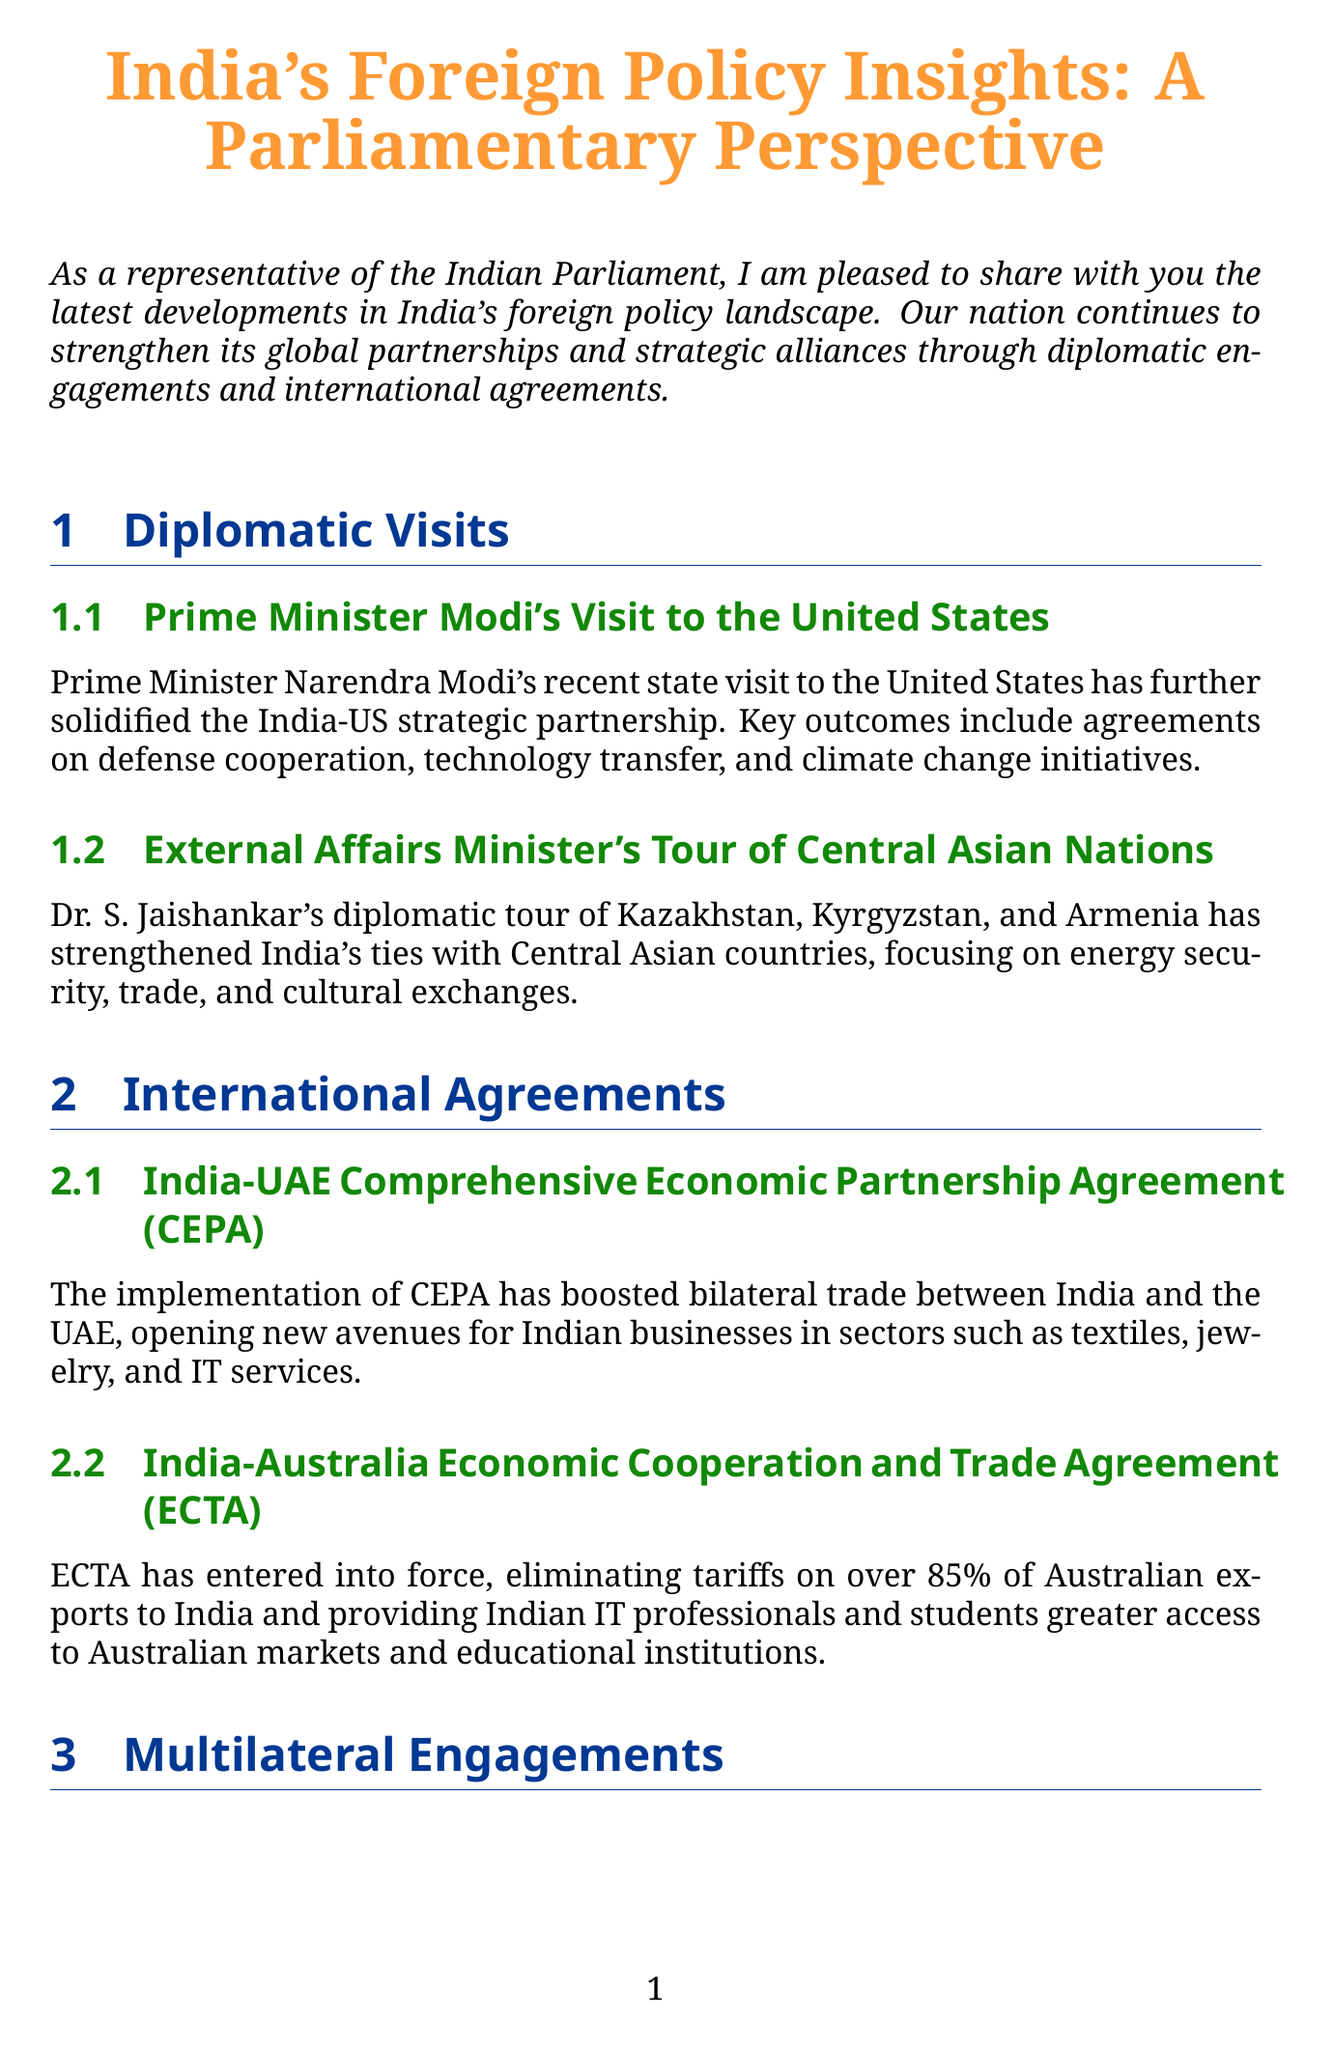What is the title of the newsletter? The title of the newsletter is found at the beginning of the document, highlighting its focus on India's foreign policy.
Answer: India's Foreign Policy Insights: A Parliamentary Perspective Who visited the United States recently? This question refers to a notable diplomatic visit mentioned in the document, specifically identifying the leader involved.
Answer: Prime Minister Modi What is one key outcome of PM Modi's visit to the US? The document lists several outcomes from the visit, focusing on a significant area of cooperation achieved.
Answer: Defense cooperation Which agreement boosts bilateral trade between India and the UAE? The document explicitly names the agreement that has facilitated trade relations between the two nations.
Answer: India-UAE Comprehensive Economic Partnership Agreement (CEPA) What percentage of Australian exports to India have tariffs eliminated under ECTA? This question seeks a specific numerical detail about the impact of ECTA as stated in the newsletter.
Answer: 85 percent What initiative focuses on regional connectivity and counter-terrorism? This question requires comprehension of India's efforts in regional initiatives mentioned in the document.
Answer: Bay of Bengal Initiative for Multi-Sectoral Technical and Economic Cooperation (BIMSTEC) How does India's G20 Presidency benefit the nation? The document explains the advantages of G20 Presidency, indicating its role in addressing specific global issues.
Answer: Leadership in addressing global challenges When is the upcoming India-Africa Forum Summit expected to occur? While the document mentions an upcoming event, it does not provide a specific date, making this a reasoning inquiry about future diplomatic engagement.
Answer: Upcoming (no specific date provided) 